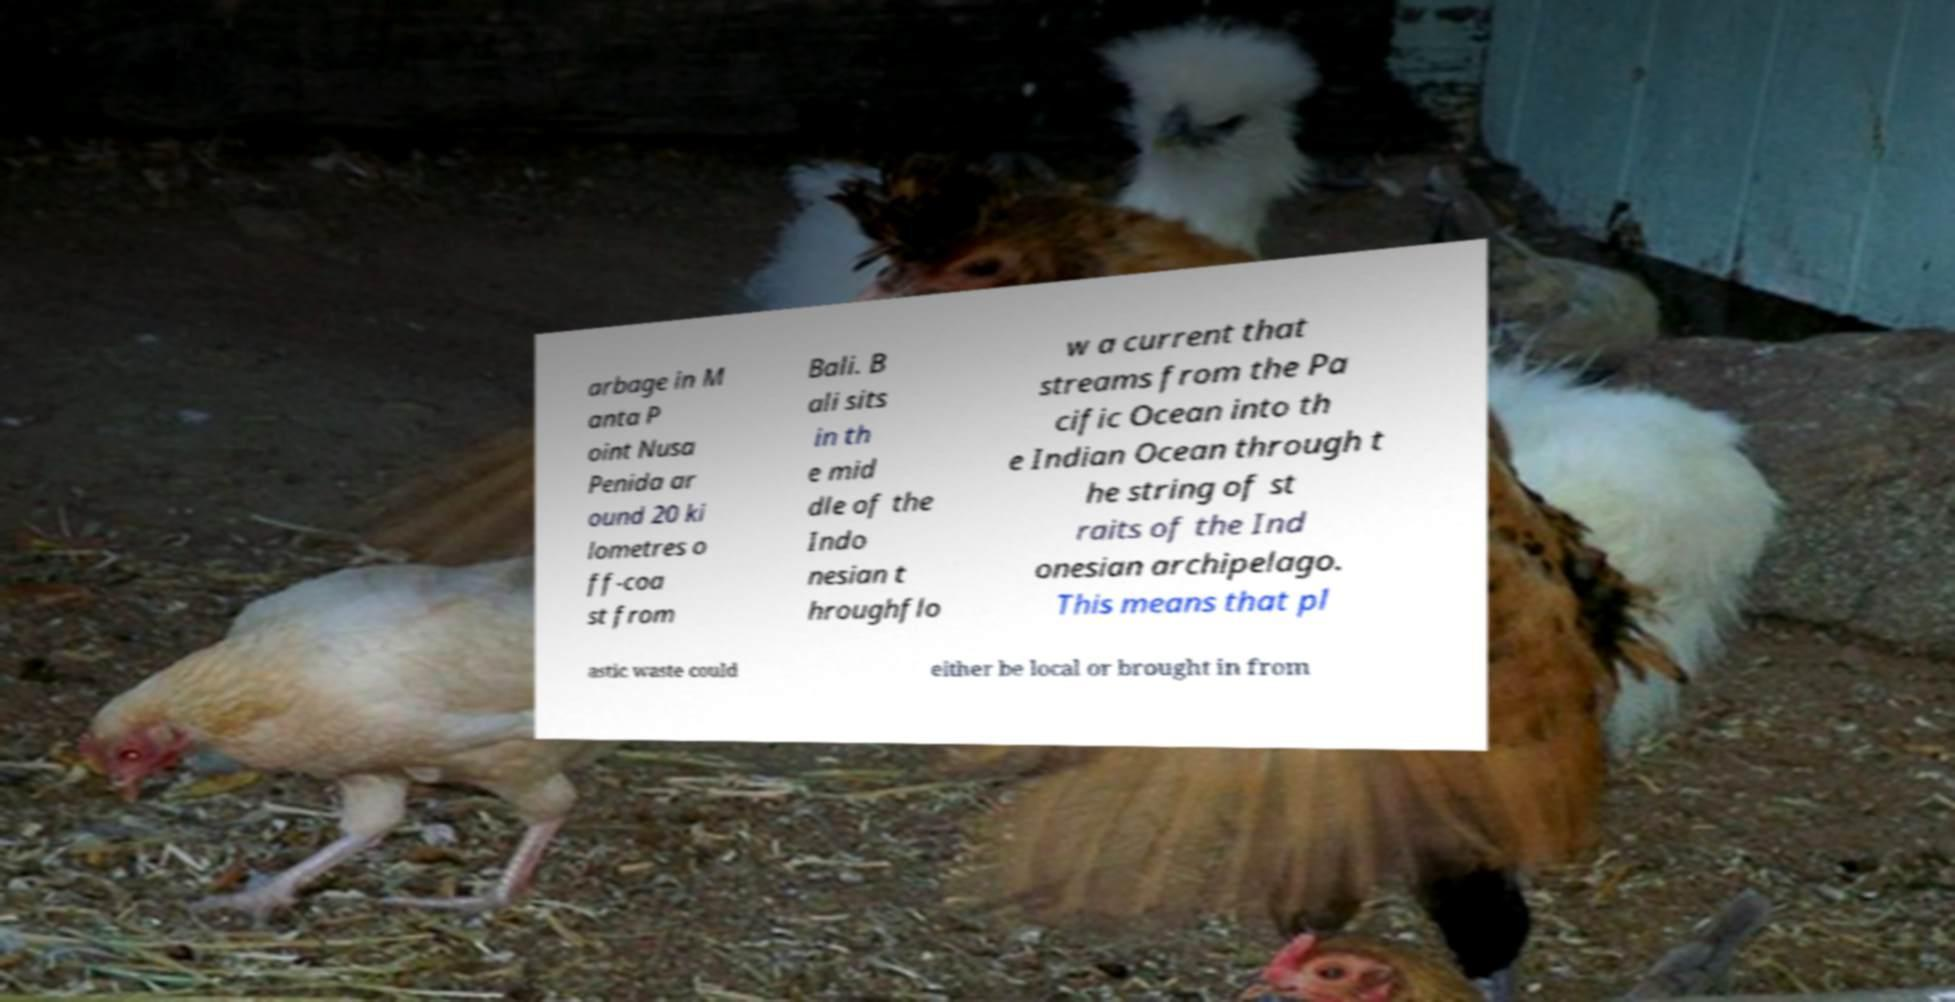What messages or text are displayed in this image? I need them in a readable, typed format. arbage in M anta P oint Nusa Penida ar ound 20 ki lometres o ff-coa st from Bali. B ali sits in th e mid dle of the Indo nesian t hroughflo w a current that streams from the Pa cific Ocean into th e Indian Ocean through t he string of st raits of the Ind onesian archipelago. This means that pl astic waste could either be local or brought in from 